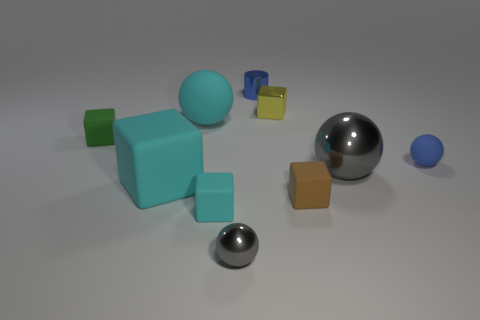How many small rubber balls are on the right side of the large ball that is behind the green thing?
Offer a very short reply. 1. There is a gray shiny ball that is on the right side of the metal ball in front of the rubber cube that is in front of the tiny brown object; what size is it?
Make the answer very short. Large. Does the big thing behind the green matte block have the same color as the big matte block?
Provide a succinct answer. Yes. The other cyan thing that is the same shape as the large shiny object is what size?
Offer a terse response. Large. What number of objects are metallic spheres that are on the left side of the large gray sphere or gray metallic balls that are behind the tiny gray object?
Your answer should be compact. 2. The large cyan rubber object behind the big matte thing in front of the big metallic thing is what shape?
Your answer should be very brief. Sphere. Is there anything else that has the same color as the tiny shiny cube?
Make the answer very short. No. How many objects are small blue cylinders or matte balls?
Make the answer very short. 3. Is there a gray metallic ball that has the same size as the metal cylinder?
Your answer should be compact. Yes. The brown rubber thing is what shape?
Your response must be concise. Cube. 